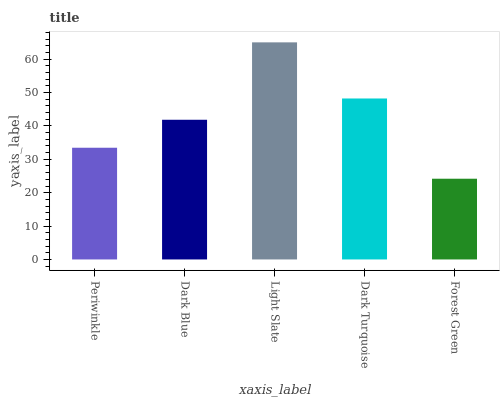Is Forest Green the minimum?
Answer yes or no. Yes. Is Light Slate the maximum?
Answer yes or no. Yes. Is Dark Blue the minimum?
Answer yes or no. No. Is Dark Blue the maximum?
Answer yes or no. No. Is Dark Blue greater than Periwinkle?
Answer yes or no. Yes. Is Periwinkle less than Dark Blue?
Answer yes or no. Yes. Is Periwinkle greater than Dark Blue?
Answer yes or no. No. Is Dark Blue less than Periwinkle?
Answer yes or no. No. Is Dark Blue the high median?
Answer yes or no. Yes. Is Dark Blue the low median?
Answer yes or no. Yes. Is Forest Green the high median?
Answer yes or no. No. Is Dark Turquoise the low median?
Answer yes or no. No. 